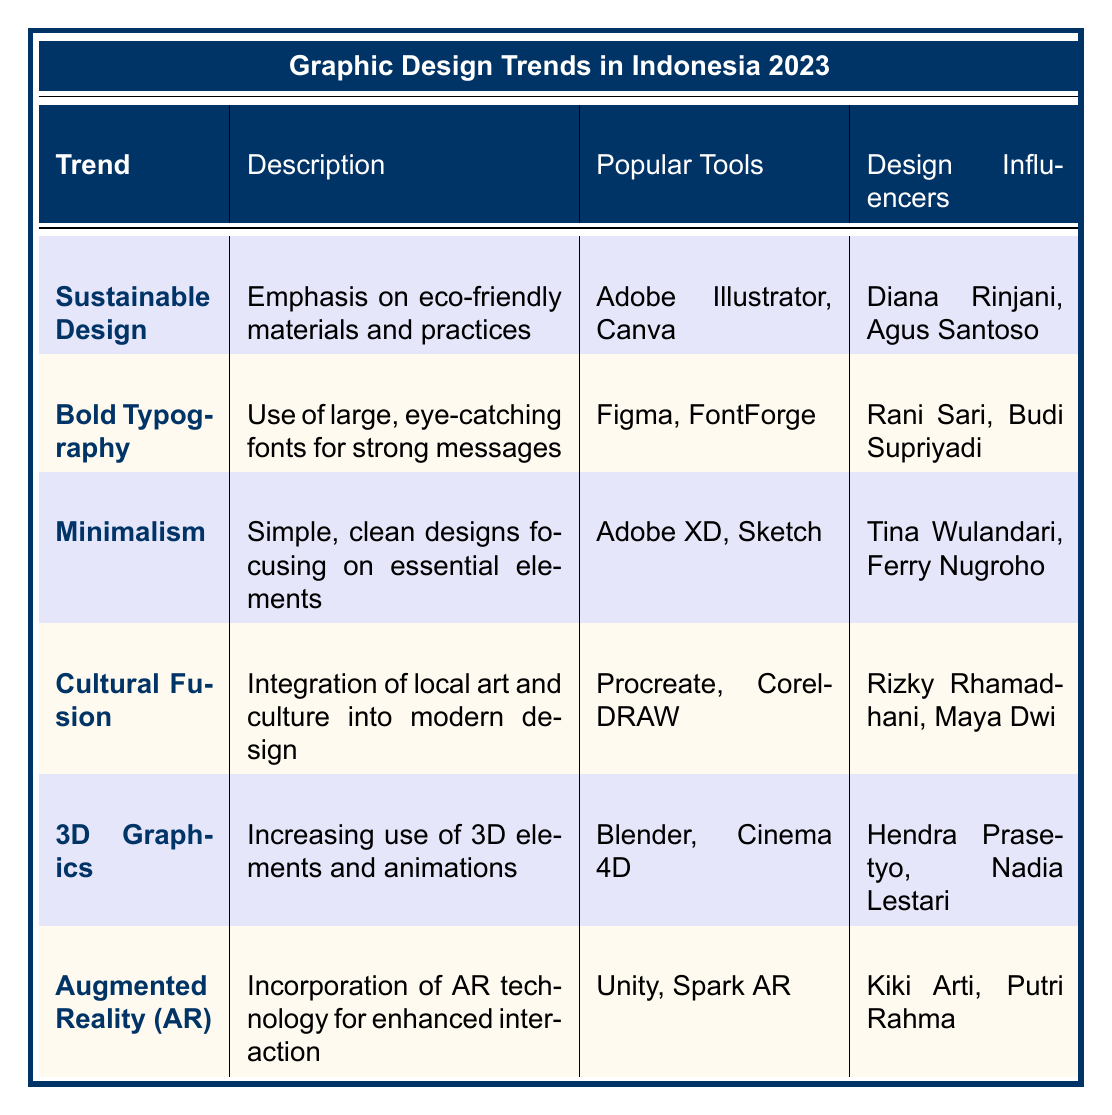What is the trend that emphasizes eco-friendly materials? The table lists "Sustainable Design" as the trend focused on eco-friendly materials and practices.
Answer: Sustainable Design Which popular tool is associated with Bold Typography? According to the table, "Figma" is listed as one of the popular tools for Bold Typography.
Answer: Figma How many design influencers are mentioned for Minimalism? The table shows that there are two design influencers for Minimalism: Tina Wulandari and Ferry Nugroho.
Answer: 2 Is Augmented Reality (AR) a graphic design trend mentioned in the table? The table indicates that Augmented Reality (AR) is indeed listed as a trend, confirming its inclusion.
Answer: Yes Which trend uses local art and culture in modern design? The table identifies "Cultural Fusion" as the trend that integrates local Indonesian art and culture into graphic design.
Answer: Cultural Fusion What are the popular tools used in 3D Graphics? The table mentions "Blender" and "Cinema 4D" as the popular tools associated with 3D Graphics.
Answer: Blender, Cinema 4D Which design influencer is associated with Augmented Reality (AR)? The table specifies "Kiki Arti" and "Putri Rahma" as the design influencers for Augmented Reality (AR).
Answer: Kiki Arti, Putri Rahma What is the common theme between Sustainable Design and Minimalism? Both trends focus on creating designs that enhance user experience, with Sustainable Design promoting eco-friendliness and Minimalism emphasizing simplicity.
Answer: Eco-friendliness and simplicity Which trend has the most examples listed in the table? The table does not explicitly indicate the number of examples; however, the trends described seem to be qualitatively similar in their example listing. Therefore, a direct comparison isn’t straightforward.
Answer: N/A Which trend might appeal to tech startups based on its description? Based on the description of Minimalism focusing on essential elements and user experience, it would likely appeal to tech startups.
Answer: Minimalism 